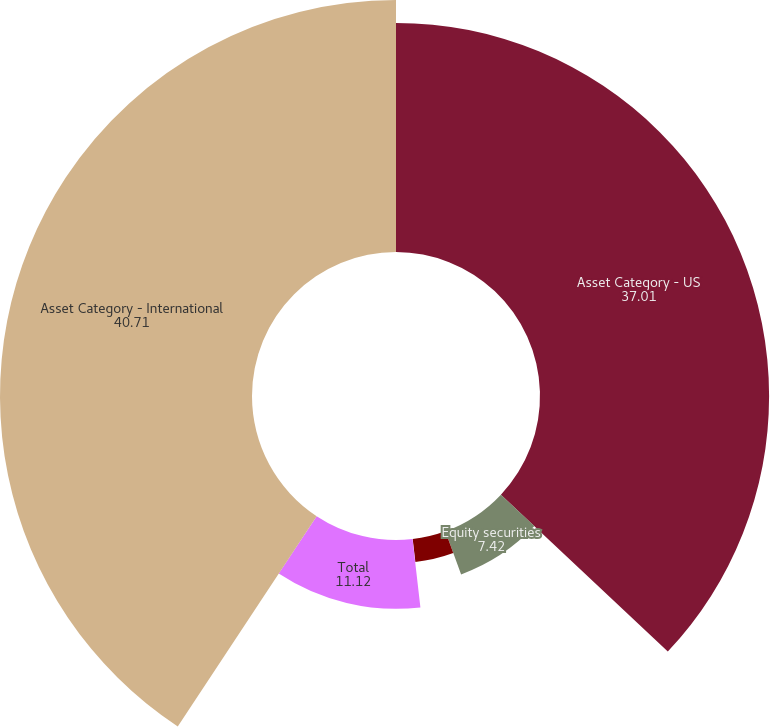Convert chart. <chart><loc_0><loc_0><loc_500><loc_500><pie_chart><fcel>Asset Category - US<fcel>Equity securities<fcel>Debt securities<fcel>Real estate and other<fcel>Total<fcel>Asset Category - International<nl><fcel>37.01%<fcel>7.42%<fcel>3.72%<fcel>0.02%<fcel>11.12%<fcel>40.71%<nl></chart> 